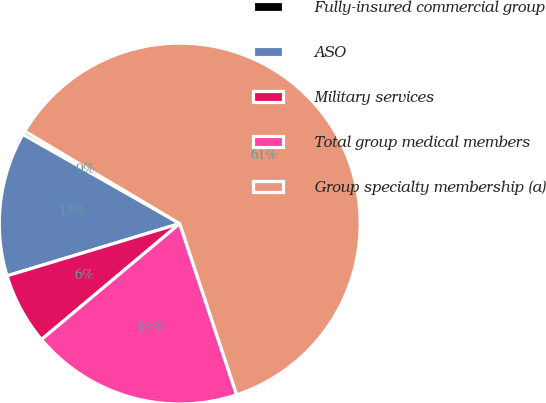Convert chart. <chart><loc_0><loc_0><loc_500><loc_500><pie_chart><fcel>Fully-insured commercial group<fcel>ASO<fcel>Military services<fcel>Total group medical members<fcel>Group specialty membership (a)<nl><fcel>0.33%<fcel>12.9%<fcel>6.43%<fcel>19.0%<fcel>61.33%<nl></chart> 